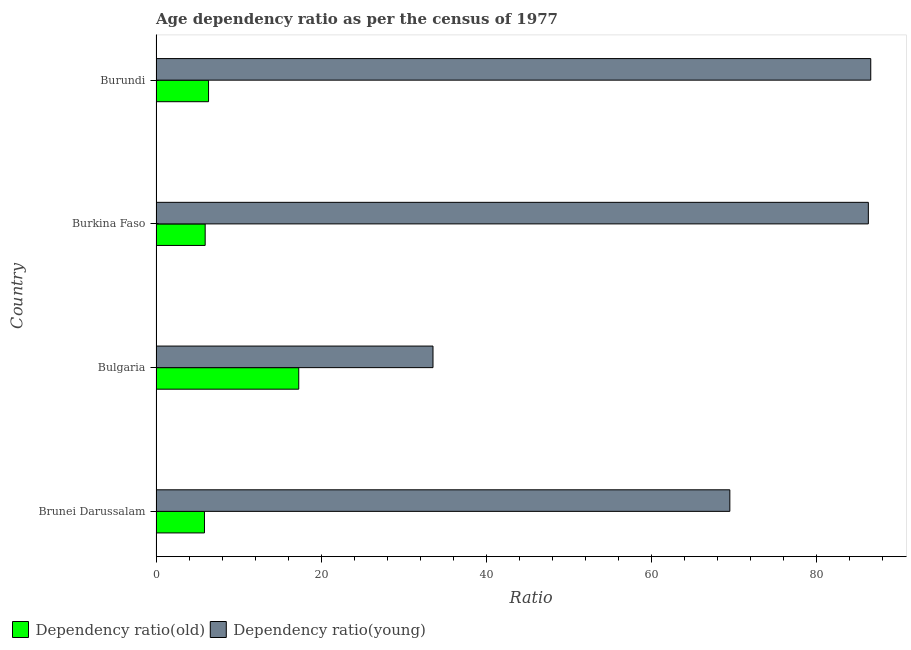How many groups of bars are there?
Make the answer very short. 4. What is the label of the 1st group of bars from the top?
Make the answer very short. Burundi. In how many cases, is the number of bars for a given country not equal to the number of legend labels?
Give a very brief answer. 0. What is the age dependency ratio(young) in Burkina Faso?
Provide a short and direct response. 86.26. Across all countries, what is the maximum age dependency ratio(old)?
Your answer should be compact. 17.28. Across all countries, what is the minimum age dependency ratio(old)?
Offer a terse response. 5.87. In which country was the age dependency ratio(old) maximum?
Provide a short and direct response. Bulgaria. In which country was the age dependency ratio(old) minimum?
Offer a terse response. Brunei Darussalam. What is the total age dependency ratio(young) in the graph?
Give a very brief answer. 275.85. What is the difference between the age dependency ratio(young) in Bulgaria and that in Burundi?
Ensure brevity in your answer.  -53.01. What is the difference between the age dependency ratio(young) in Bulgaria and the age dependency ratio(old) in Burkina Faso?
Make the answer very short. 27.59. What is the average age dependency ratio(old) per country?
Ensure brevity in your answer.  8.87. What is the difference between the age dependency ratio(old) and age dependency ratio(young) in Brunei Darussalam?
Ensure brevity in your answer.  -63.62. In how many countries, is the age dependency ratio(old) greater than 32 ?
Offer a very short reply. 0. What is the ratio of the age dependency ratio(old) in Bulgaria to that in Burkina Faso?
Give a very brief answer. 2.9. Is the difference between the age dependency ratio(young) in Brunei Darussalam and Burundi greater than the difference between the age dependency ratio(old) in Brunei Darussalam and Burundi?
Make the answer very short. No. What is the difference between the highest and the second highest age dependency ratio(young)?
Give a very brief answer. 0.29. What is the difference between the highest and the lowest age dependency ratio(old)?
Your answer should be very brief. 11.42. Is the sum of the age dependency ratio(young) in Burkina Faso and Burundi greater than the maximum age dependency ratio(old) across all countries?
Offer a very short reply. Yes. What does the 1st bar from the top in Burundi represents?
Offer a very short reply. Dependency ratio(young). What does the 2nd bar from the bottom in Burkina Faso represents?
Your answer should be compact. Dependency ratio(young). Are all the bars in the graph horizontal?
Make the answer very short. Yes. How many countries are there in the graph?
Give a very brief answer. 4. Does the graph contain any zero values?
Offer a terse response. No. Does the graph contain grids?
Give a very brief answer. No. What is the title of the graph?
Provide a short and direct response. Age dependency ratio as per the census of 1977. Does "Primary school" appear as one of the legend labels in the graph?
Offer a very short reply. No. What is the label or title of the X-axis?
Keep it short and to the point. Ratio. What is the Ratio of Dependency ratio(old) in Brunei Darussalam?
Offer a very short reply. 5.87. What is the Ratio of Dependency ratio(young) in Brunei Darussalam?
Ensure brevity in your answer.  69.49. What is the Ratio of Dependency ratio(old) in Bulgaria?
Offer a very short reply. 17.28. What is the Ratio in Dependency ratio(young) in Bulgaria?
Ensure brevity in your answer.  33.54. What is the Ratio of Dependency ratio(old) in Burkina Faso?
Make the answer very short. 5.95. What is the Ratio in Dependency ratio(young) in Burkina Faso?
Make the answer very short. 86.26. What is the Ratio in Dependency ratio(old) in Burundi?
Offer a terse response. 6.36. What is the Ratio in Dependency ratio(young) in Burundi?
Provide a short and direct response. 86.55. Across all countries, what is the maximum Ratio of Dependency ratio(old)?
Your answer should be compact. 17.28. Across all countries, what is the maximum Ratio in Dependency ratio(young)?
Ensure brevity in your answer.  86.55. Across all countries, what is the minimum Ratio in Dependency ratio(old)?
Give a very brief answer. 5.87. Across all countries, what is the minimum Ratio in Dependency ratio(young)?
Your answer should be compact. 33.54. What is the total Ratio of Dependency ratio(old) in the graph?
Your response must be concise. 35.46. What is the total Ratio of Dependency ratio(young) in the graph?
Your answer should be compact. 275.85. What is the difference between the Ratio of Dependency ratio(old) in Brunei Darussalam and that in Bulgaria?
Ensure brevity in your answer.  -11.42. What is the difference between the Ratio in Dependency ratio(young) in Brunei Darussalam and that in Bulgaria?
Make the answer very short. 35.95. What is the difference between the Ratio in Dependency ratio(old) in Brunei Darussalam and that in Burkina Faso?
Provide a short and direct response. -0.08. What is the difference between the Ratio of Dependency ratio(young) in Brunei Darussalam and that in Burkina Faso?
Give a very brief answer. -16.77. What is the difference between the Ratio of Dependency ratio(old) in Brunei Darussalam and that in Burundi?
Make the answer very short. -0.49. What is the difference between the Ratio in Dependency ratio(young) in Brunei Darussalam and that in Burundi?
Offer a very short reply. -17.06. What is the difference between the Ratio of Dependency ratio(old) in Bulgaria and that in Burkina Faso?
Ensure brevity in your answer.  11.33. What is the difference between the Ratio of Dependency ratio(young) in Bulgaria and that in Burkina Faso?
Offer a terse response. -52.72. What is the difference between the Ratio in Dependency ratio(old) in Bulgaria and that in Burundi?
Ensure brevity in your answer.  10.92. What is the difference between the Ratio in Dependency ratio(young) in Bulgaria and that in Burundi?
Provide a succinct answer. -53.01. What is the difference between the Ratio of Dependency ratio(old) in Burkina Faso and that in Burundi?
Keep it short and to the point. -0.41. What is the difference between the Ratio of Dependency ratio(young) in Burkina Faso and that in Burundi?
Your response must be concise. -0.29. What is the difference between the Ratio in Dependency ratio(old) in Brunei Darussalam and the Ratio in Dependency ratio(young) in Bulgaria?
Your answer should be compact. -27.67. What is the difference between the Ratio in Dependency ratio(old) in Brunei Darussalam and the Ratio in Dependency ratio(young) in Burkina Faso?
Offer a very short reply. -80.39. What is the difference between the Ratio in Dependency ratio(old) in Brunei Darussalam and the Ratio in Dependency ratio(young) in Burundi?
Your answer should be very brief. -80.69. What is the difference between the Ratio in Dependency ratio(old) in Bulgaria and the Ratio in Dependency ratio(young) in Burkina Faso?
Provide a short and direct response. -68.98. What is the difference between the Ratio of Dependency ratio(old) in Bulgaria and the Ratio of Dependency ratio(young) in Burundi?
Provide a short and direct response. -69.27. What is the difference between the Ratio of Dependency ratio(old) in Burkina Faso and the Ratio of Dependency ratio(young) in Burundi?
Offer a terse response. -80.6. What is the average Ratio in Dependency ratio(old) per country?
Provide a short and direct response. 8.87. What is the average Ratio in Dependency ratio(young) per country?
Your answer should be compact. 68.96. What is the difference between the Ratio in Dependency ratio(old) and Ratio in Dependency ratio(young) in Brunei Darussalam?
Offer a very short reply. -63.62. What is the difference between the Ratio in Dependency ratio(old) and Ratio in Dependency ratio(young) in Bulgaria?
Give a very brief answer. -16.26. What is the difference between the Ratio in Dependency ratio(old) and Ratio in Dependency ratio(young) in Burkina Faso?
Provide a short and direct response. -80.31. What is the difference between the Ratio of Dependency ratio(old) and Ratio of Dependency ratio(young) in Burundi?
Your answer should be compact. -80.19. What is the ratio of the Ratio of Dependency ratio(old) in Brunei Darussalam to that in Bulgaria?
Offer a terse response. 0.34. What is the ratio of the Ratio in Dependency ratio(young) in Brunei Darussalam to that in Bulgaria?
Your response must be concise. 2.07. What is the ratio of the Ratio in Dependency ratio(old) in Brunei Darussalam to that in Burkina Faso?
Your answer should be compact. 0.99. What is the ratio of the Ratio in Dependency ratio(young) in Brunei Darussalam to that in Burkina Faso?
Keep it short and to the point. 0.81. What is the ratio of the Ratio of Dependency ratio(old) in Brunei Darussalam to that in Burundi?
Offer a terse response. 0.92. What is the ratio of the Ratio in Dependency ratio(young) in Brunei Darussalam to that in Burundi?
Your answer should be compact. 0.8. What is the ratio of the Ratio of Dependency ratio(old) in Bulgaria to that in Burkina Faso?
Provide a succinct answer. 2.9. What is the ratio of the Ratio in Dependency ratio(young) in Bulgaria to that in Burkina Faso?
Make the answer very short. 0.39. What is the ratio of the Ratio in Dependency ratio(old) in Bulgaria to that in Burundi?
Offer a terse response. 2.72. What is the ratio of the Ratio in Dependency ratio(young) in Bulgaria to that in Burundi?
Your answer should be compact. 0.39. What is the ratio of the Ratio in Dependency ratio(old) in Burkina Faso to that in Burundi?
Offer a very short reply. 0.94. What is the ratio of the Ratio of Dependency ratio(young) in Burkina Faso to that in Burundi?
Provide a succinct answer. 1. What is the difference between the highest and the second highest Ratio of Dependency ratio(old)?
Provide a short and direct response. 10.92. What is the difference between the highest and the second highest Ratio in Dependency ratio(young)?
Your answer should be compact. 0.29. What is the difference between the highest and the lowest Ratio in Dependency ratio(old)?
Give a very brief answer. 11.42. What is the difference between the highest and the lowest Ratio in Dependency ratio(young)?
Keep it short and to the point. 53.01. 